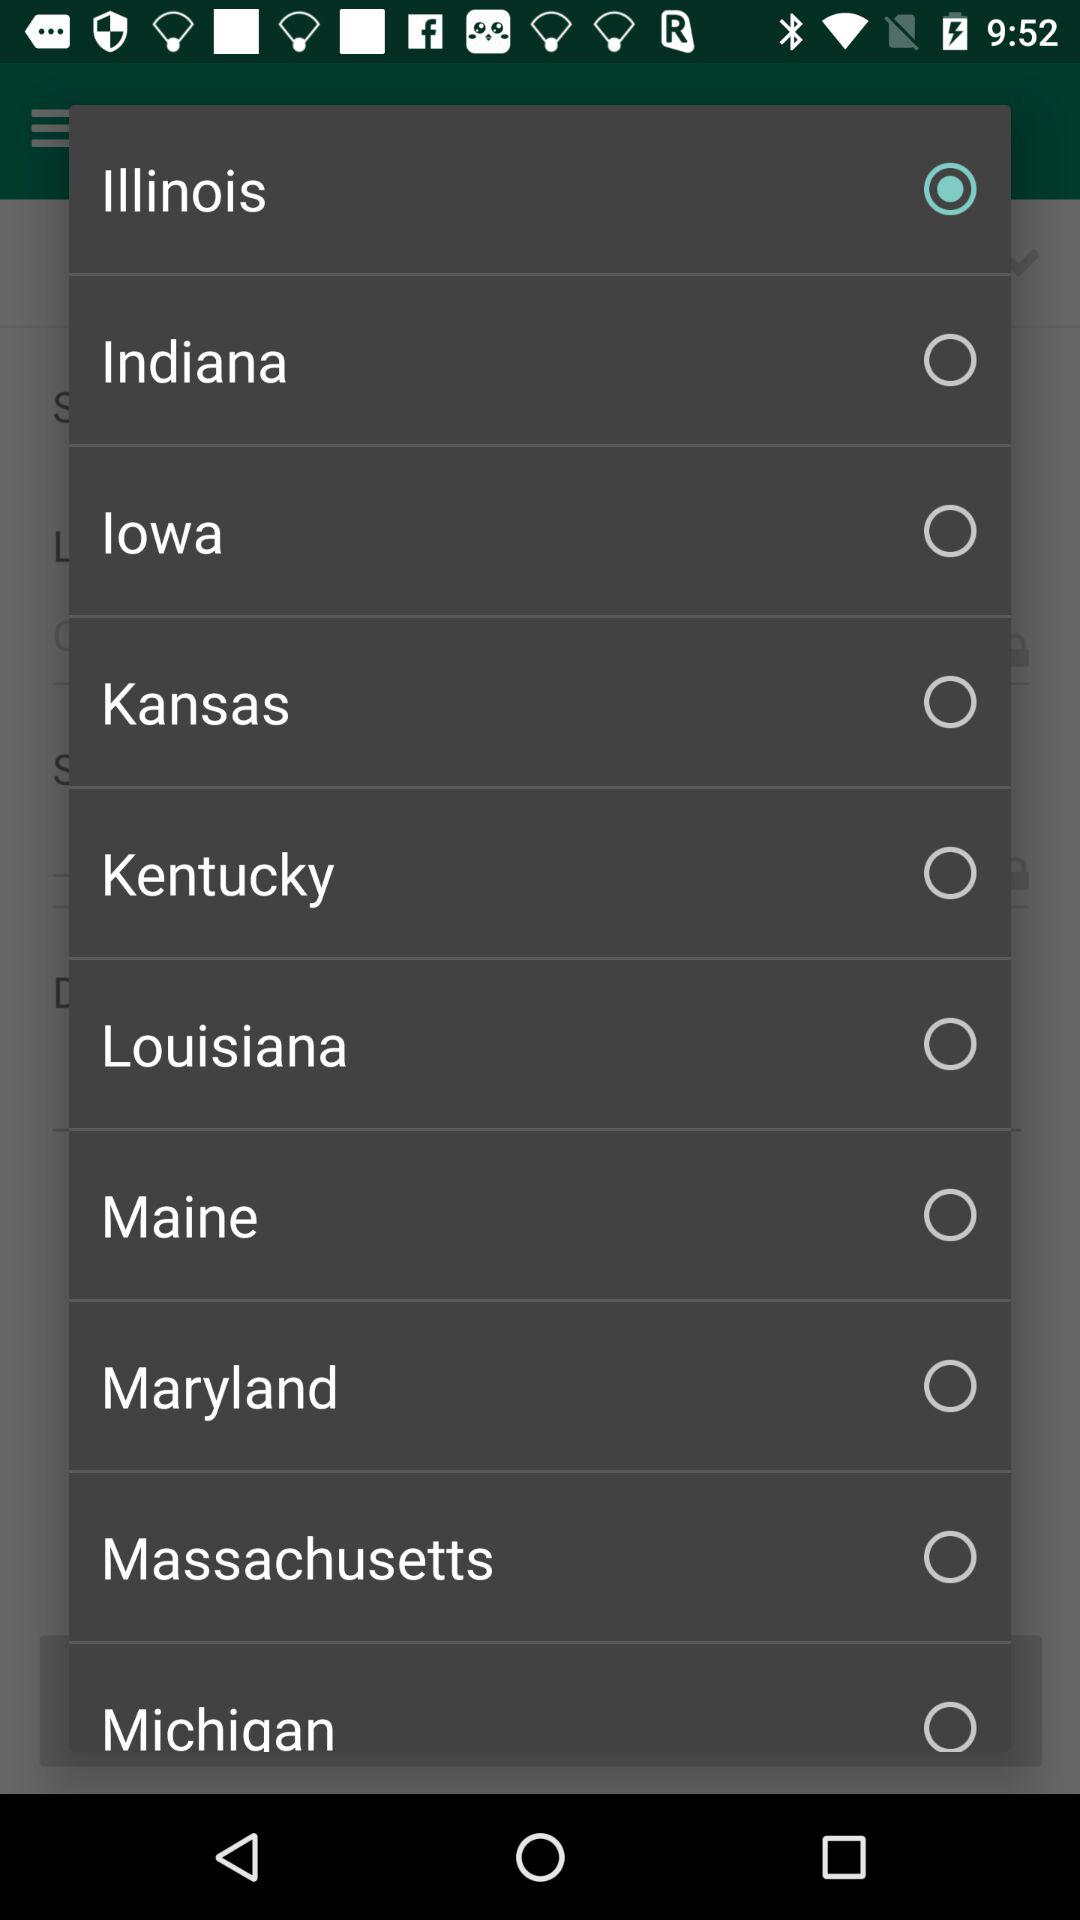What is the status of "lowa"? The status of "lowa" is "off". 